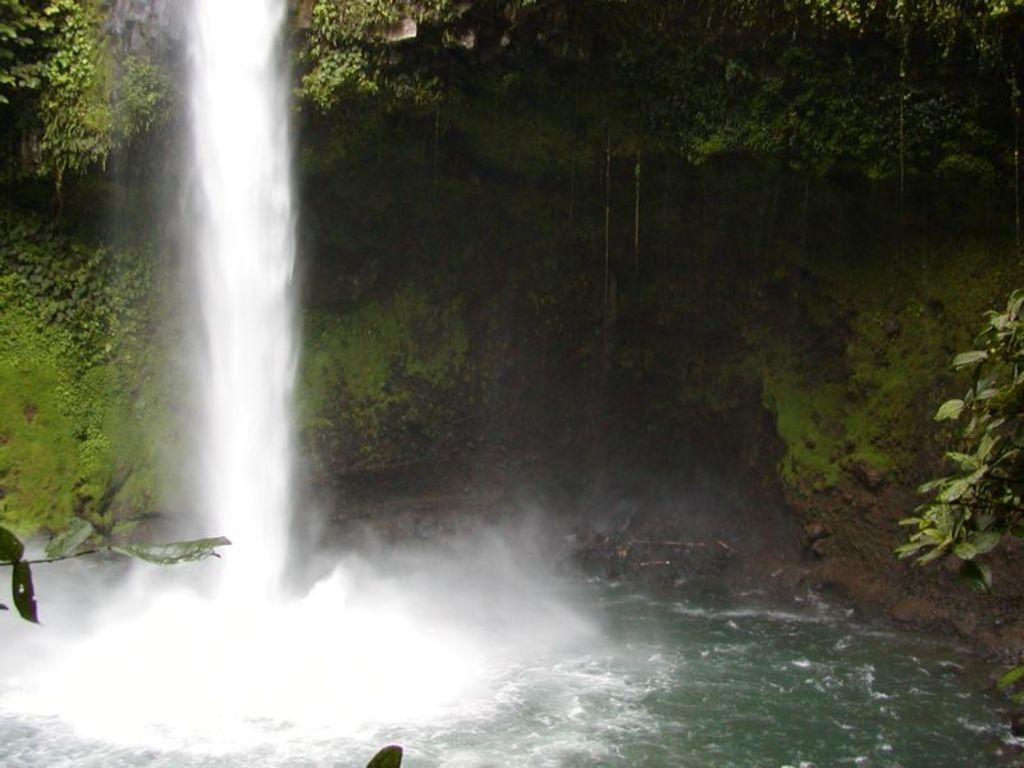What is at the bottom of the image? There is water at the bottom of the image. What can be seen in the middle of the image? There are trees in the middle of the image. What type of drug can be seen in the image? There is no drug present in the image. What letters are visible in the image? There is no mention of letters in the provided facts, so we cannot determine if any are present in the image. 